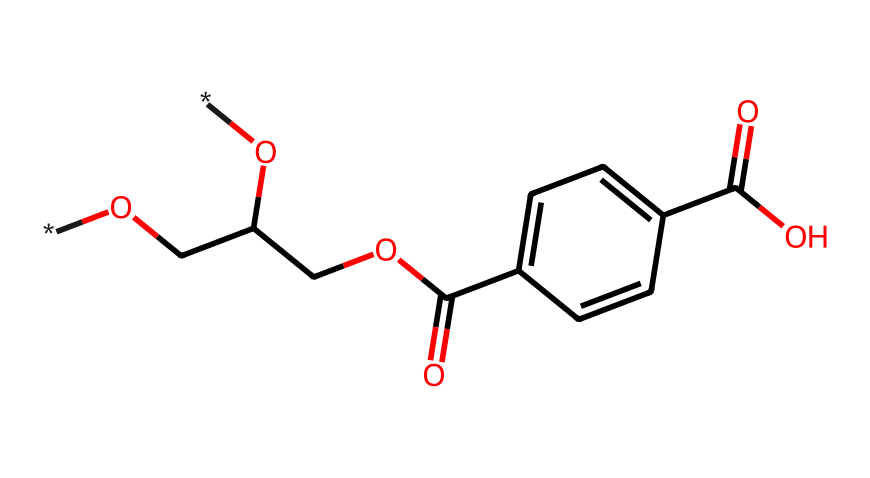What is the chemical name of this structure? The SMILES representation corresponds to polyethylene terephthalate, which is a widely used polymer. The presence of the ester functional groups and the aromatic rings in the structure are indicators of its identity.
Answer: polyethylene terephthalate How many carbon atoms are in the structure? By counting the carbon atoms represented in the SMILES notation, there are 10 carbon atoms linked through various bonds and functional groups.
Answer: 10 What type of polymer is formed from this monomer? This structure is a monomer of a polyester, as it contains ester linkages formed from the reaction between alcohol and carboxylic acid functionalities.
Answer: polyester What functional groups are present in this structure? The chemical has hydroxyl (-OH) and carboxylic acid (-COOH) functional groups, which can be identified by their specific bonding patterns and presence in the SMILES.
Answer: hydroxyl and carboxylic acid How many hydroxyl groups are present in the structure? There are two -OH groups present in the molecular structure, as indicated by the two separate locations of the hydroxyl groups in the SMILES representation.
Answer: 2 What is the significance of the aromatic ring in this chemical? The aromatic ring provides rigidity and stability to the polymer structure, which contributes to the mechanical properties of the polyester when it is synthesized.
Answer: rigidity and stability Which part of the structure is responsible for its ability to form strong fibers? The repetitive ester linkages formed between the monomer units create a strong crystalline region in the polymer chain, improving fiber strength and durability.
Answer: ester linkages 